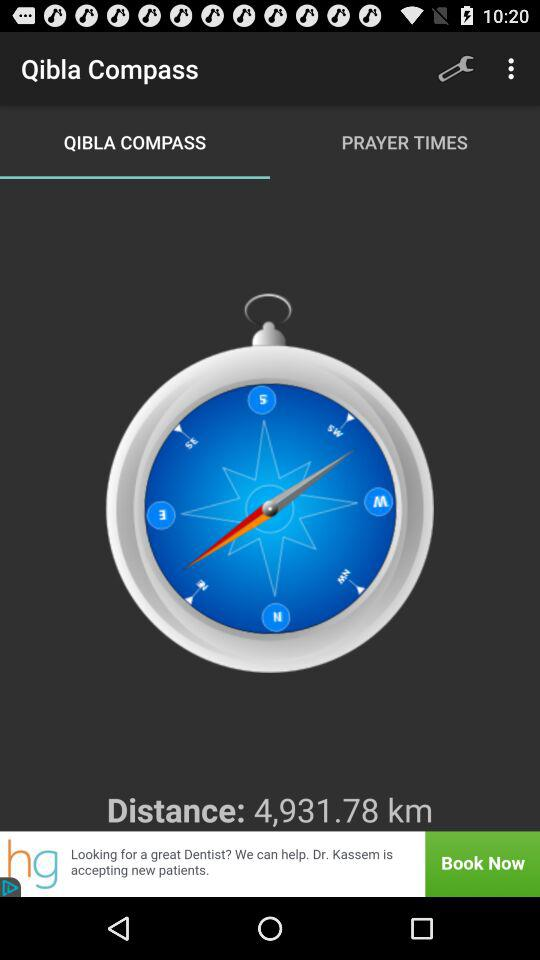How much is the distance? The distance is 4,931.78 km. 